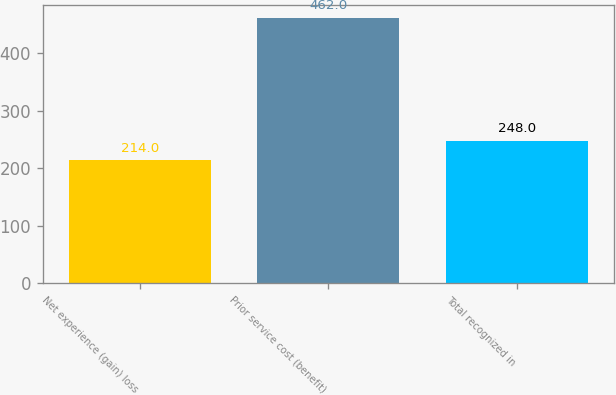<chart> <loc_0><loc_0><loc_500><loc_500><bar_chart><fcel>Net experience (gain) loss<fcel>Prior service cost (benefit)<fcel>Total recognized in<nl><fcel>214<fcel>462<fcel>248<nl></chart> 